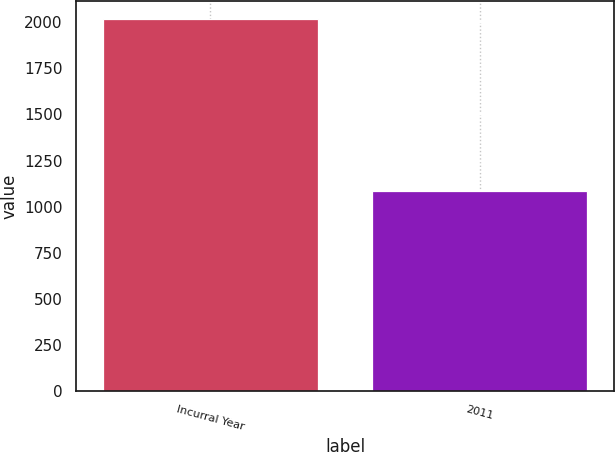Convert chart to OTSL. <chart><loc_0><loc_0><loc_500><loc_500><bar_chart><fcel>Incurral Year<fcel>2011<nl><fcel>2016<fcel>1087<nl></chart> 